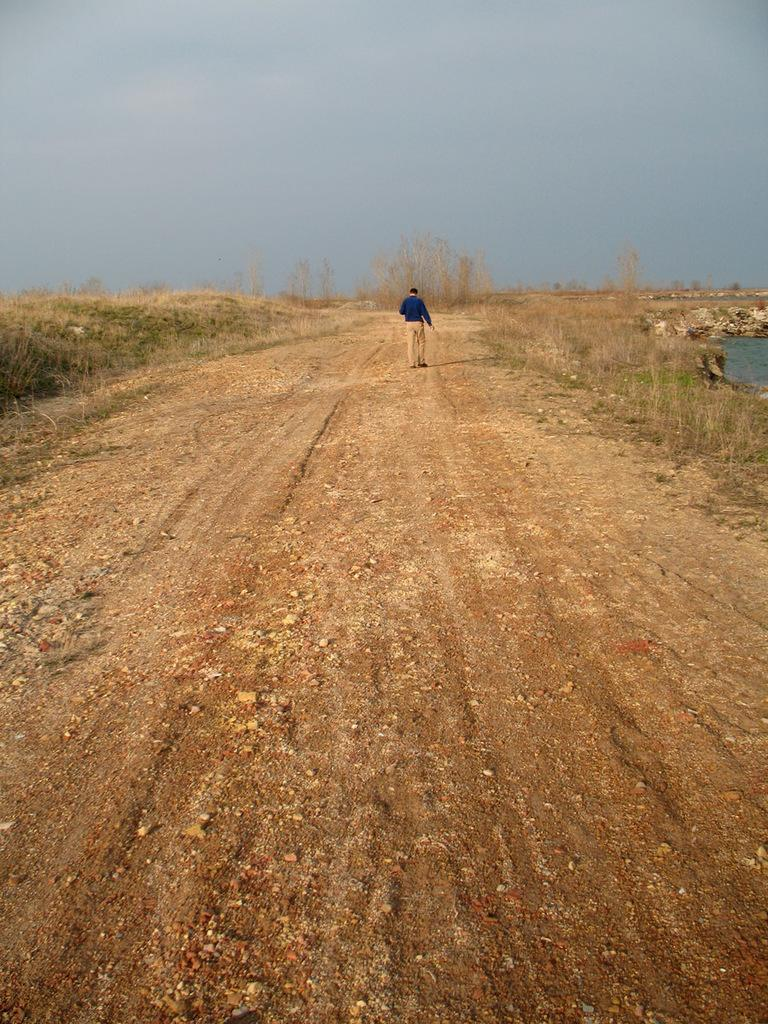What is present in the image? There is a person in the image. What is the person wearing? The person is wearing clothes. What type of natural environment can be seen in the image? There is grass and water visible in the image. Is there any man-made structure in the image? Yes, there is a path in the image. What part of the natural environment is visible in the image? The sky is visible in the image. What type of noise is the root making in the image? There is no root present in the image, and therefore no noise can be attributed to it. 